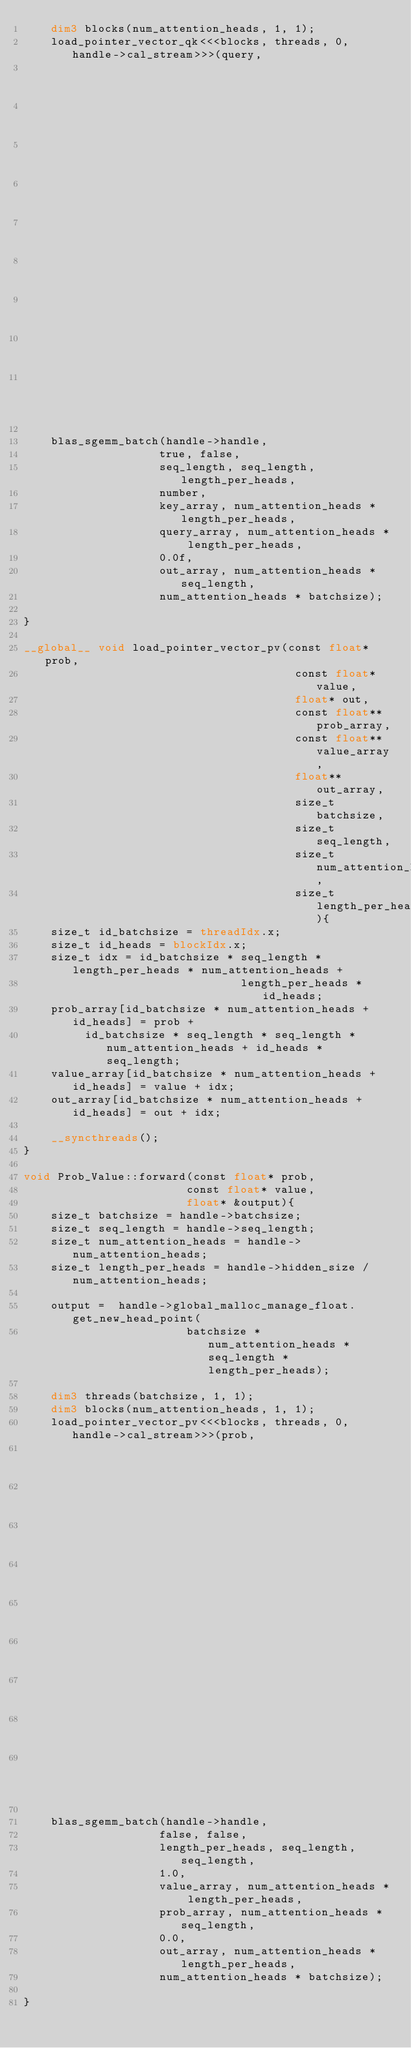Convert code to text. <code><loc_0><loc_0><loc_500><loc_500><_Cuda_>    dim3 blocks(num_attention_heads, 1, 1);
    load_pointer_vector_qk<<<blocks, threads, 0, handle->cal_stream>>>(query,
                                                                       key,
                                                                       output,
                                                                       query_array,
                                                                       key_array,
                                                                       out_array,
                                                                       batchsize,
                                                                       seq_length,
                                                                       num_attention_heads,
                                                                       length_per_heads);
    
    blas_sgemm_batch(handle->handle,
                    true, false,
                    seq_length, seq_length, length_per_heads,
                    number,
                    key_array, num_attention_heads * length_per_heads,
                    query_array, num_attention_heads * length_per_heads,
                    0.0f,
                    out_array, num_attention_heads * seq_length,
                    num_attention_heads * batchsize);
    
}

__global__ void load_pointer_vector_pv(const float* prob,
                                        const float* value,
                                        float* out,
                                        const float** prob_array,
                                        const float** value_array,
                                        float** out_array,
                                        size_t batchsize,
                                        size_t seq_length,
                                        size_t num_attention_heads,
                                        size_t length_per_heads){
    size_t id_batchsize = threadIdx.x;
    size_t id_heads = blockIdx.x;
    size_t idx = id_batchsize * seq_length * length_per_heads * num_attention_heads +
                                length_per_heads * id_heads;
    prob_array[id_batchsize * num_attention_heads + id_heads] = prob +         
         id_batchsize * seq_length * seq_length * num_attention_heads + id_heads * seq_length;
    value_array[id_batchsize * num_attention_heads + id_heads] = value + idx;
    out_array[id_batchsize * num_attention_heads + id_heads] = out + idx;

    __syncthreads();
}

void Prob_Value::forward(const float* prob,
                        const float* value,
                        float* &output){
    size_t batchsize = handle->batchsize;
    size_t seq_length = handle->seq_length;
    size_t num_attention_heads = handle->num_attention_heads;
    size_t length_per_heads = handle->hidden_size / num_attention_heads;

    output =  handle->global_malloc_manage_float.get_new_head_point(
                        batchsize * num_attention_heads * seq_length * length_per_heads);
    
    dim3 threads(batchsize, 1, 1);
    dim3 blocks(num_attention_heads, 1, 1);
    load_pointer_vector_pv<<<blocks, threads, 0, handle->cal_stream>>>(prob,
                                                                       value,
                                                                       output,
                                                                       prob_array,
                                                                       value_array,
                                                                       out_array,
                                                                       batchsize,
                                                                       seq_length,
                                                                       num_attention_heads,
                                                                       length_per_heads);
    
    blas_sgemm_batch(handle->handle,
                    false, false,
                    length_per_heads, seq_length, seq_length,
                    1.0,
                    value_array, num_attention_heads * length_per_heads,
                    prob_array, num_attention_heads * seq_length,
                    0.0,
                    out_array, num_attention_heads * length_per_heads,
                    num_attention_heads * batchsize);
    
}</code> 